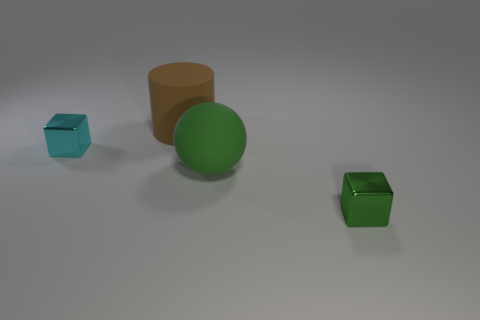Can you tell me how many objects are there in total? Sure, there are a total of four objects in the image: one cylinder, one sphere, and two cubes. 